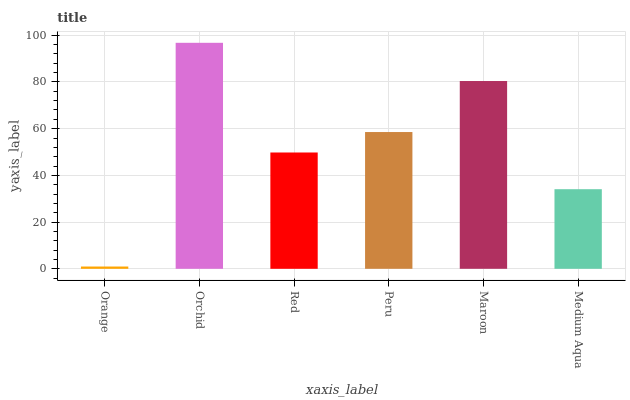Is Orange the minimum?
Answer yes or no. Yes. Is Orchid the maximum?
Answer yes or no. Yes. Is Red the minimum?
Answer yes or no. No. Is Red the maximum?
Answer yes or no. No. Is Orchid greater than Red?
Answer yes or no. Yes. Is Red less than Orchid?
Answer yes or no. Yes. Is Red greater than Orchid?
Answer yes or no. No. Is Orchid less than Red?
Answer yes or no. No. Is Peru the high median?
Answer yes or no. Yes. Is Red the low median?
Answer yes or no. Yes. Is Orchid the high median?
Answer yes or no. No. Is Orchid the low median?
Answer yes or no. No. 